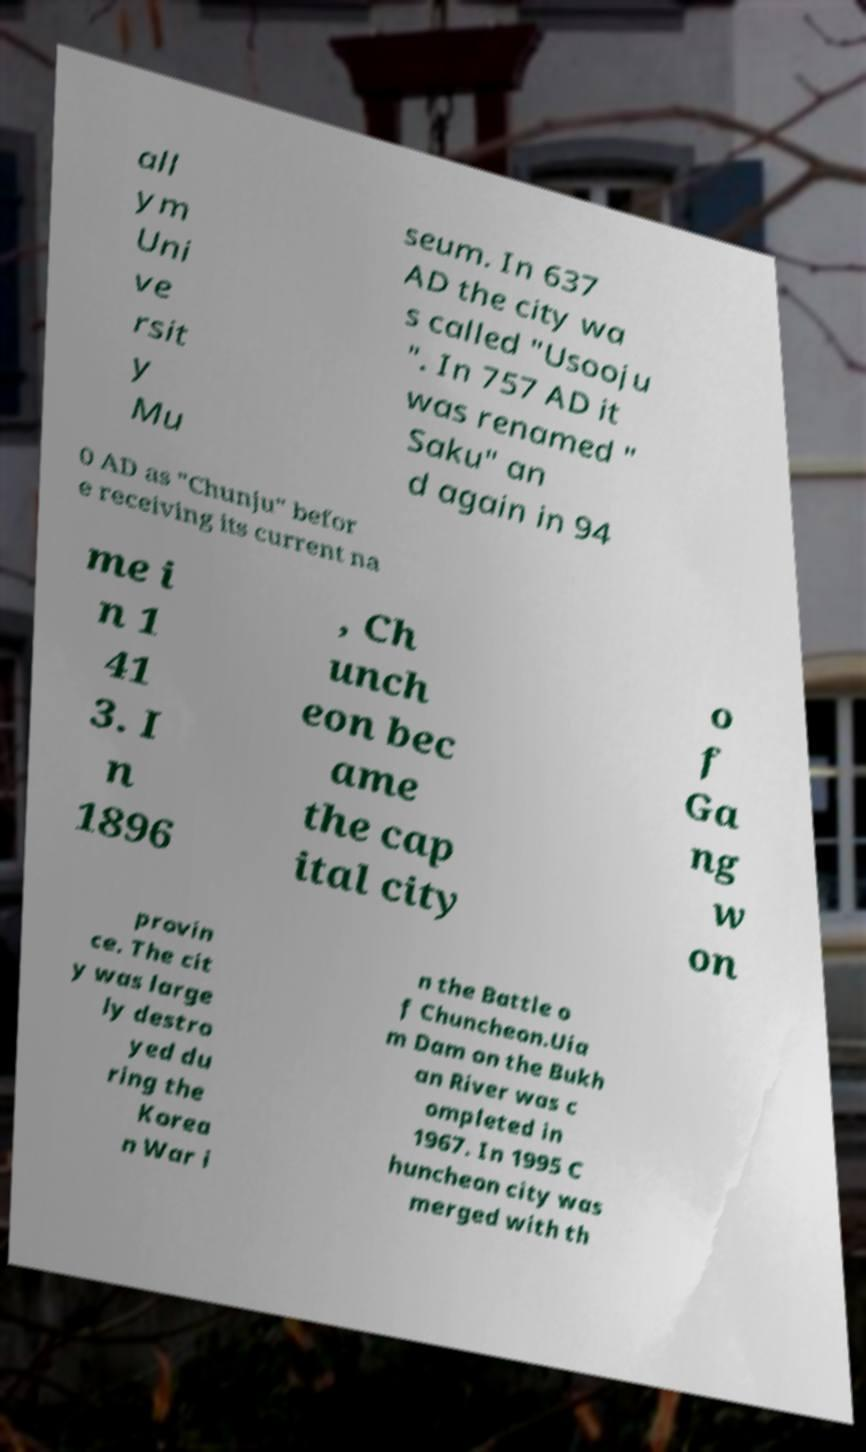Could you assist in decoding the text presented in this image and type it out clearly? all ym Uni ve rsit y Mu seum. In 637 AD the city wa s called "Usooju ". In 757 AD it was renamed " Saku" an d again in 94 0 AD as "Chunju" befor e receiving its current na me i n 1 41 3. I n 1896 , Ch unch eon bec ame the cap ital city o f Ga ng w on provin ce. The cit y was large ly destro yed du ring the Korea n War i n the Battle o f Chuncheon.Uia m Dam on the Bukh an River was c ompleted in 1967. In 1995 C huncheon city was merged with th 